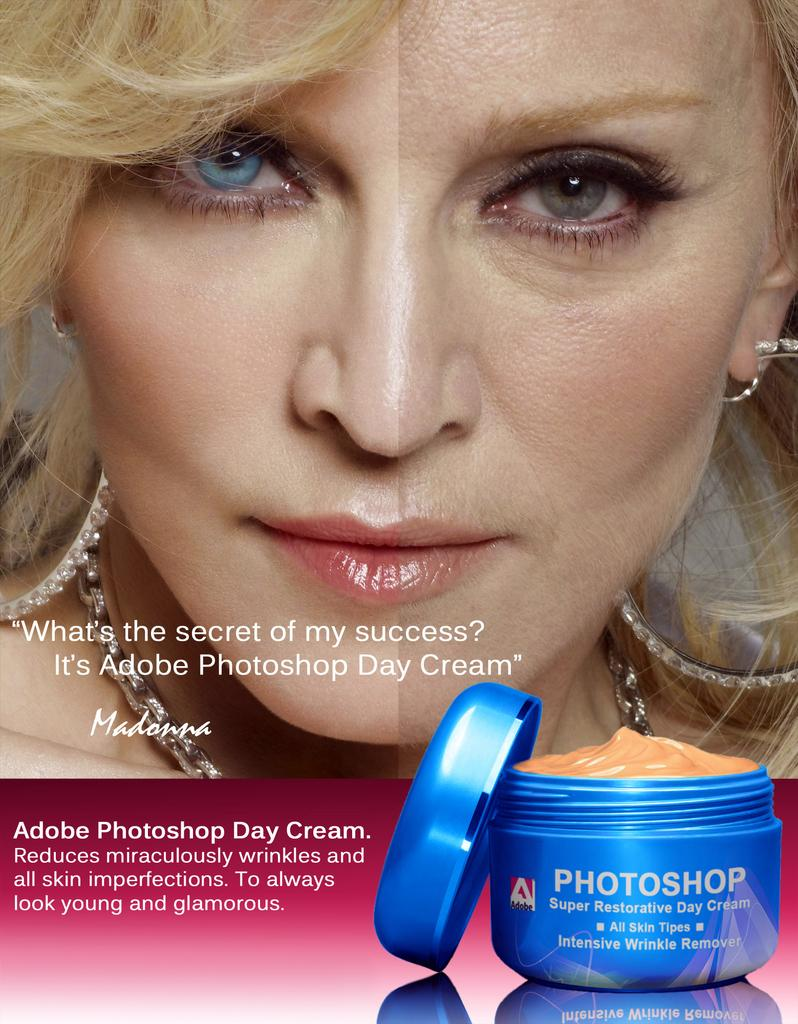<image>
Write a terse but informative summary of the picture. Madonna poses for an ad for Adobe Photoshop Day Cream 